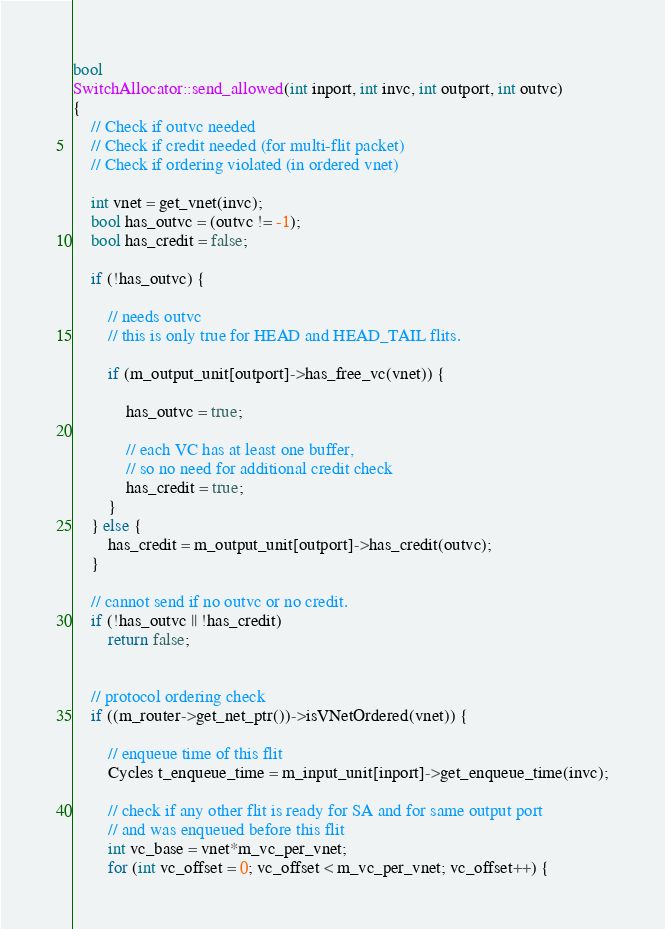<code> <loc_0><loc_0><loc_500><loc_500><_C++_>bool
SwitchAllocator::send_allowed(int inport, int invc, int outport, int outvc)
{
    // Check if outvc needed
    // Check if credit needed (for multi-flit packet)
    // Check if ordering violated (in ordered vnet)

    int vnet = get_vnet(invc);
    bool has_outvc = (outvc != -1);
    bool has_credit = false;

    if (!has_outvc) {

        // needs outvc
        // this is only true for HEAD and HEAD_TAIL flits.

        if (m_output_unit[outport]->has_free_vc(vnet)) {

            has_outvc = true;

            // each VC has at least one buffer,
            // so no need for additional credit check
            has_credit = true;
        }
    } else {
        has_credit = m_output_unit[outport]->has_credit(outvc);
    }

    // cannot send if no outvc or no credit.
    if (!has_outvc || !has_credit)
        return false;


    // protocol ordering check
    if ((m_router->get_net_ptr())->isVNetOrdered(vnet)) {

        // enqueue time of this flit
        Cycles t_enqueue_time = m_input_unit[inport]->get_enqueue_time(invc);

        // check if any other flit is ready for SA and for same output port
        // and was enqueued before this flit
        int vc_base = vnet*m_vc_per_vnet;
        for (int vc_offset = 0; vc_offset < m_vc_per_vnet; vc_offset++) {</code> 